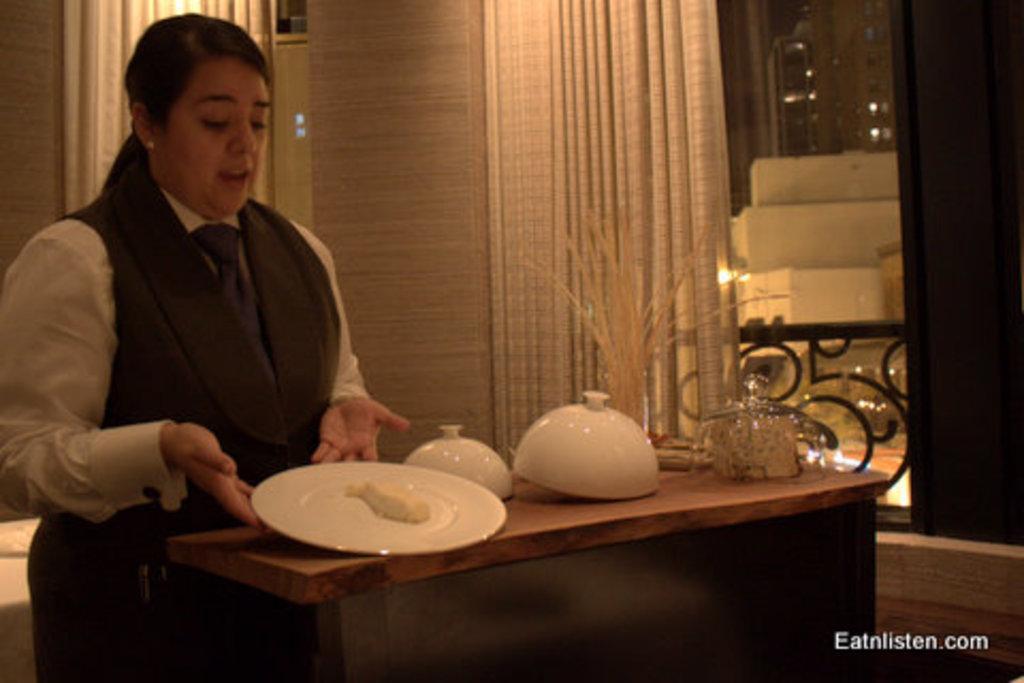How would you summarize this image in a sentence or two? In this picture we can see bowls and a plate on the table, a woman is holding the plate with the help of her hands, in the background we can see curtains. 